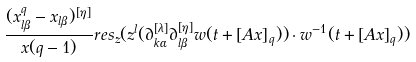Convert formula to latex. <formula><loc_0><loc_0><loc_500><loc_500>\frac { ( x _ { l \beta } ^ { q } - x _ { l \beta } ) ^ { [ \eta ] } } { x ( q - 1 ) } r e s _ { z } ( z ^ { l } ( \partial _ { k \alpha } ^ { [ \lambda ] } \partial _ { l \beta } ^ { [ \eta ] } w ( t + { [ A x ] } _ { q } ) ) \cdot w ^ { - 1 } ( t + { [ A x ] } _ { q } ) )</formula> 